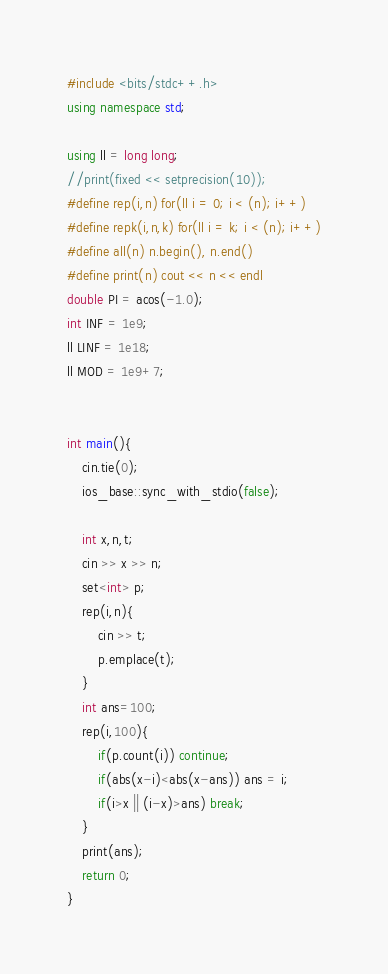<code> <loc_0><loc_0><loc_500><loc_500><_C++_>#include <bits/stdc++.h>
using namespace std;

using ll = long long;
//print(fixed << setprecision(10));
#define rep(i,n) for(ll i = 0; i < (n); i++)
#define repk(i,n,k) for(ll i = k; i < (n); i++)
#define all(n) n.begin(), n.end()
#define print(n) cout << n << endl
double PI = acos(-1.0);
int INF = 1e9;
ll LINF = 1e18;
ll MOD = 1e9+7;


int main(){
    cin.tie(0);
    ios_base::sync_with_stdio(false);
    
    int x,n,t;
    cin >> x >> n;
    set<int> p;
    rep(i,n){
        cin >> t;
        p.emplace(t);
    }
    int ans=100;
    rep(i,100){
        if(p.count(i)) continue;
        if(abs(x-i)<abs(x-ans)) ans = i;
        if(i>x || (i-x)>ans) break;
    }
    print(ans);
    return 0;
}</code> 